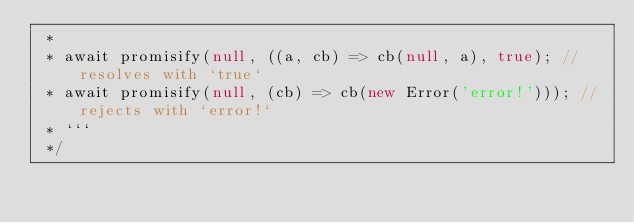<code> <loc_0><loc_0><loc_500><loc_500><_TypeScript_> *
 * await promisify(null, ((a, cb) => cb(null, a), true); // resolves with `true`
 * await promisify(null, (cb) => cb(new Error('error!'))); // rejects with `error!`
 * ```
 */</code> 